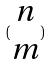Convert formula to latex. <formula><loc_0><loc_0><loc_500><loc_500>( \begin{matrix} n \\ m \end{matrix} )</formula> 